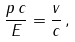Convert formula to latex. <formula><loc_0><loc_0><loc_500><loc_500>\frac { p \, c } { E } = \frac { v } { c } \, ,</formula> 